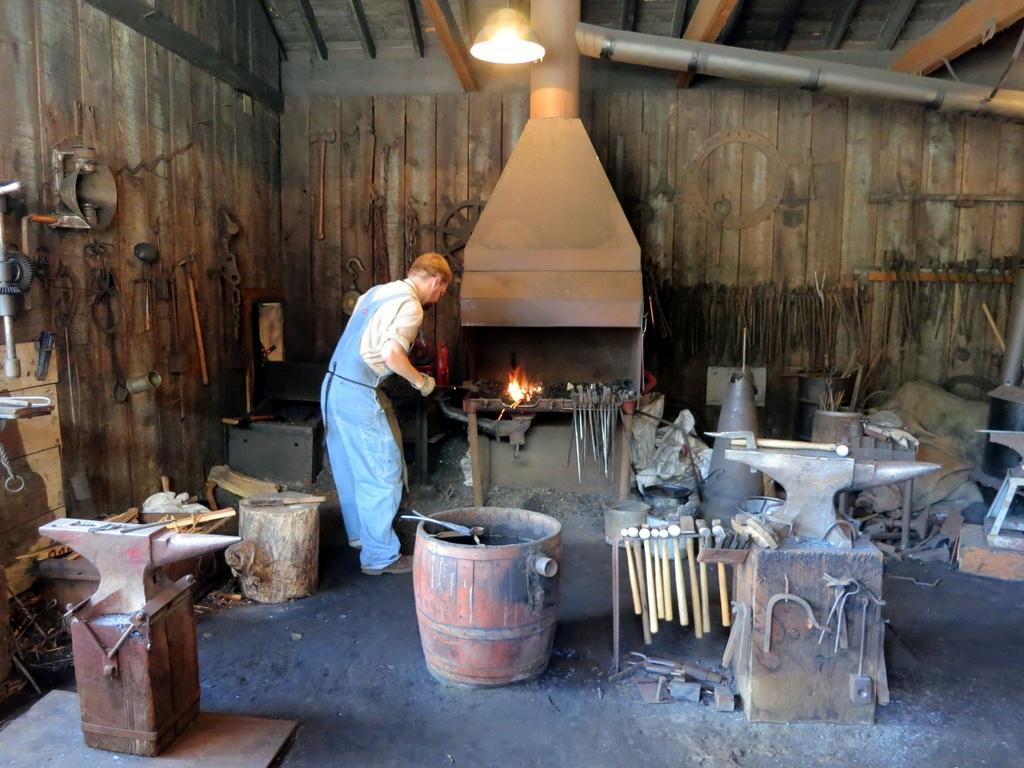How would you summarize this image in a sentence or two? In the center of the image, we can see a person wearing uniform and in the background, there are some machines, axes, a fire and we can see some other objects hanging on the wooden wall. At the top, there is a light and some rods and we can see some logs and there is wood on the floor. 